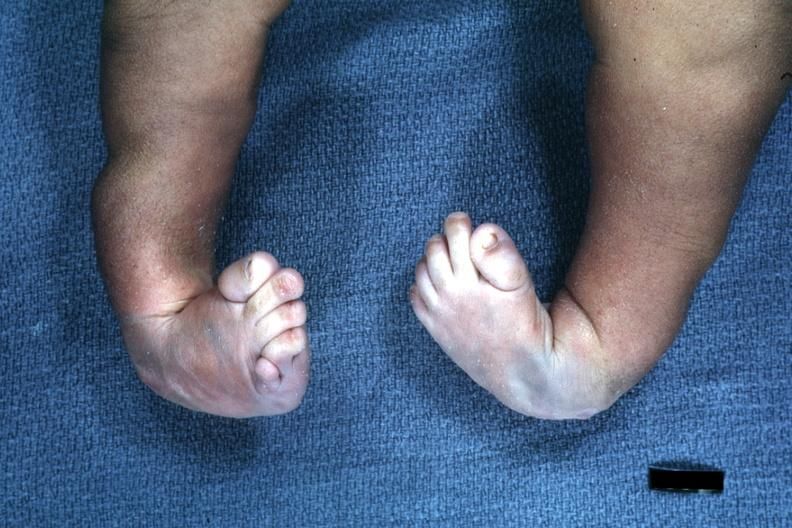does this image show infant with club feet?
Answer the question using a single word or phrase. Yes 